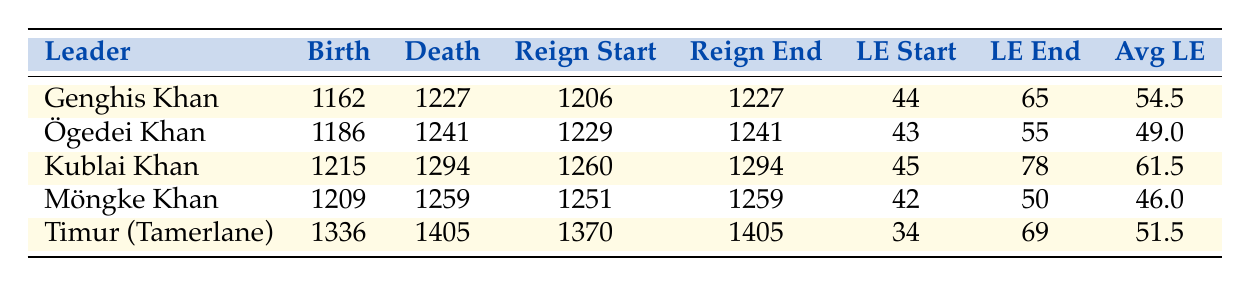What is the average life expectancy of Genghis Khan at the start of his reign? From the table, Genghis Khan's life expectancy at the start of his reign is listed as 44.
Answer: 44 Which leader had the highest life expectancy at the end of their reign? By examining the "LE End" (Life Expectancy End) column, Kublai Khan has the highest value at 78.
Answer: 78 What was Ögedei Khan's average life expectancy? The average life expectancy for Ögedei Khan, as given in the table, is 49.
Answer: 49 Did Timur (Tamerlane) live longer on average than Genghis Khan? The average life expectancy for Timur is 51.5, which is greater than Genghis Khan's average of 54.5. Therefore, the statement is false.
Answer: No How many years did Kublai Khan reign? Kublai Khan's reign started in 1260 and ended in 1294. Calculating the difference gives 1294 - 1260 = 34 years of reign.
Answer: 34 What is the difference in life expectancy at the end of reign between Ögedei Khan and Möngke Khan? Ögedei Khan's life expectancy at the end of his reign is 55, while Möngke Khan's is 50. The difference is calculated as 55 - 50 = 5.
Answer: 5 Which leader had the smallest increase in life expectancy from the start to the end of their reign? Analyzing the life expectancy increase for each leader: Genghis Khan: 65 - 44 = 21, Ögedei Khan: 55 - 43 = 12, Kublai Khan: 78 - 45 = 33, Möngke Khan: 50 - 42 = 8, Timur: 69 - 34 = 35. Möngke Khan has the smallest increase of 8 years.
Answer: Möngke Khan What was the life expectancy of Kublai Khan at the start of his reign compared to Timur's? Kublai Khan had a life expectancy at the start of his reign of 45, while Timur had 34. Comparing these two, Kublai Khan lived 11 years longer at the start of his reign.
Answer: 11 